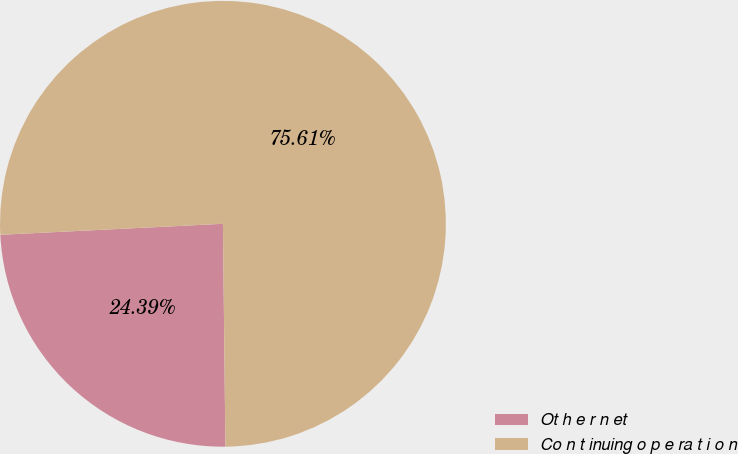Convert chart to OTSL. <chart><loc_0><loc_0><loc_500><loc_500><pie_chart><fcel>Ot h e r n et<fcel>Co n t inuing o p e ra t i o n<nl><fcel>24.39%<fcel>75.61%<nl></chart> 